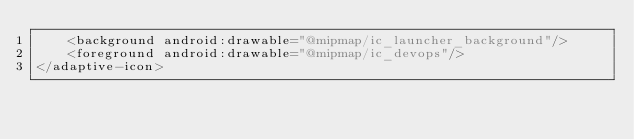Convert code to text. <code><loc_0><loc_0><loc_500><loc_500><_XML_>    <background android:drawable="@mipmap/ic_launcher_background"/>
    <foreground android:drawable="@mipmap/ic_devops"/>
</adaptive-icon></code> 